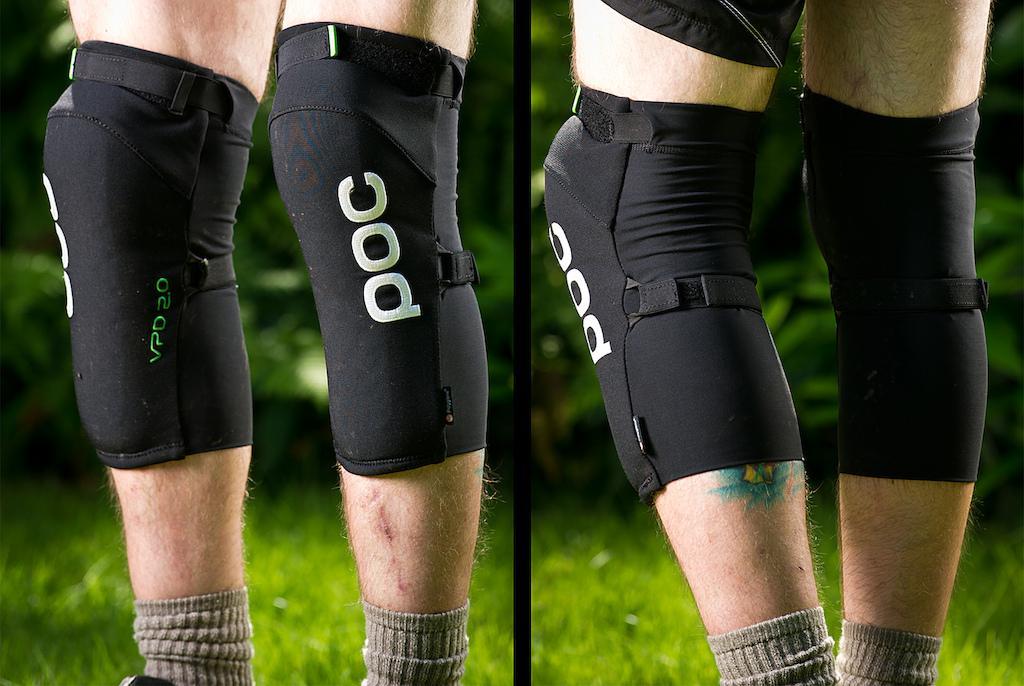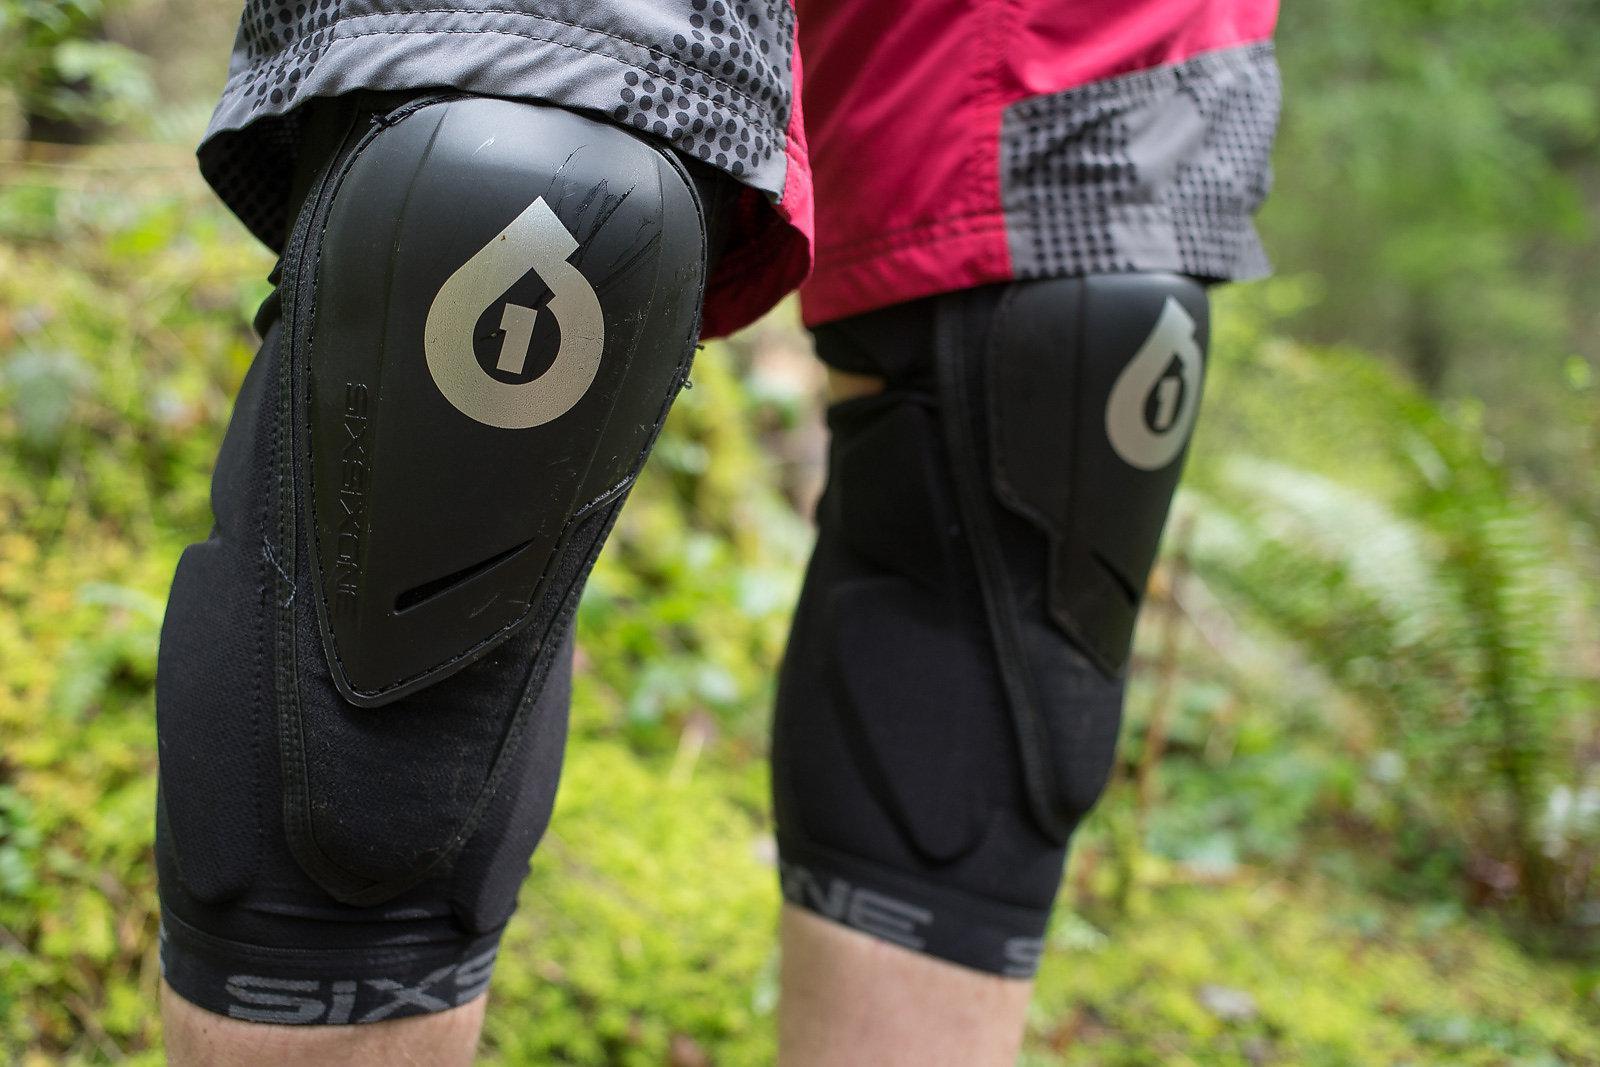The first image is the image on the left, the second image is the image on the right. Evaluate the accuracy of this statement regarding the images: "At least one knee pad is not worn by a human.". Is it true? Answer yes or no. No. 